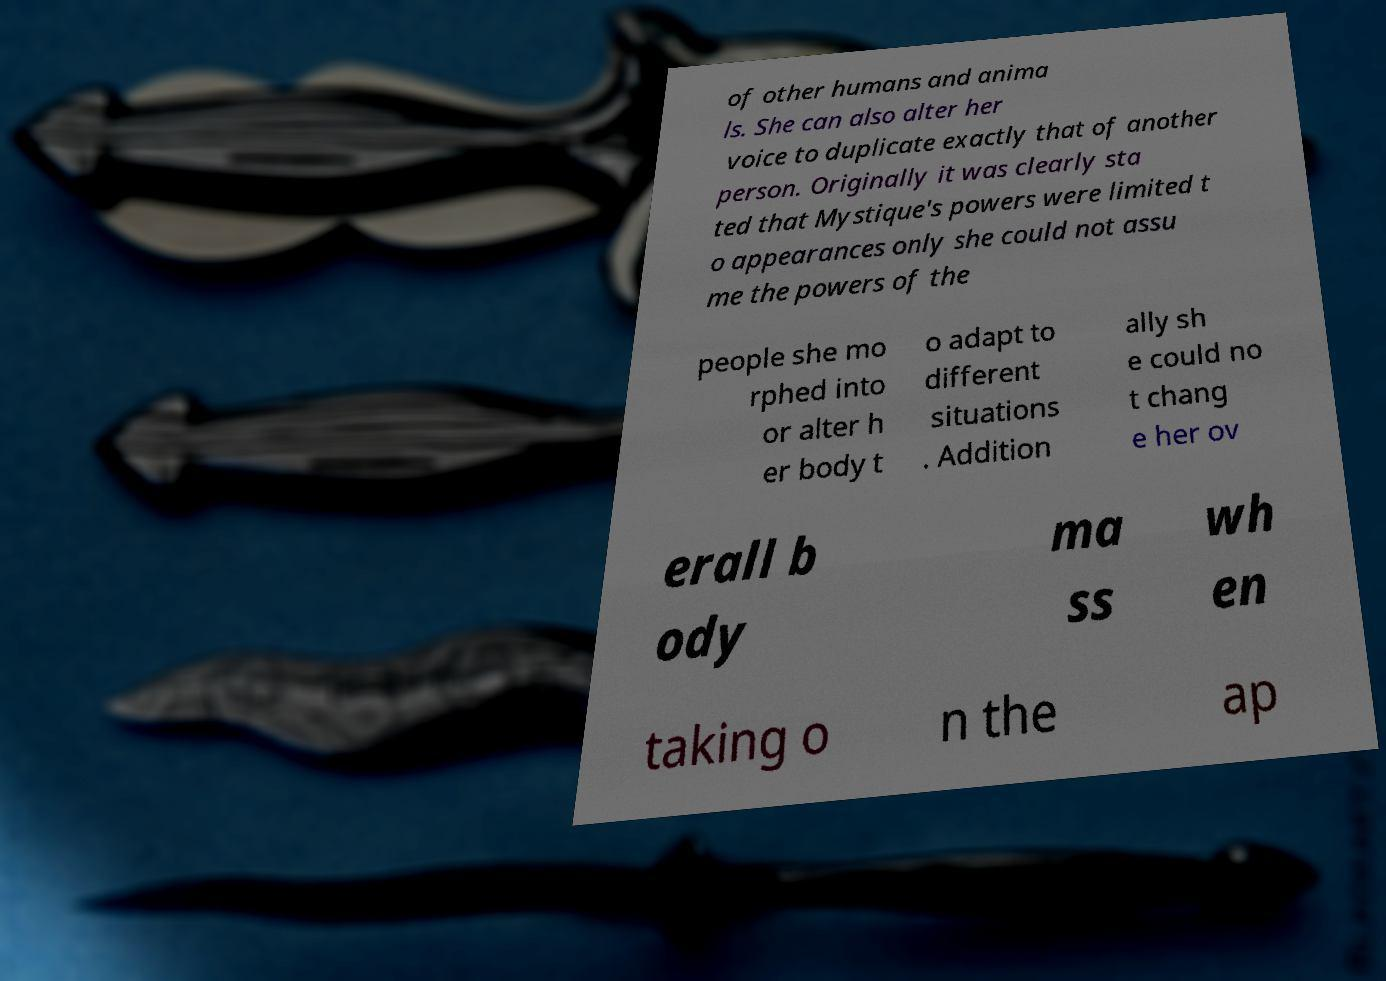Can you read and provide the text displayed in the image?This photo seems to have some interesting text. Can you extract and type it out for me? of other humans and anima ls. She can also alter her voice to duplicate exactly that of another person. Originally it was clearly sta ted that Mystique's powers were limited t o appearances only she could not assu me the powers of the people she mo rphed into or alter h er body t o adapt to different situations . Addition ally sh e could no t chang e her ov erall b ody ma ss wh en taking o n the ap 